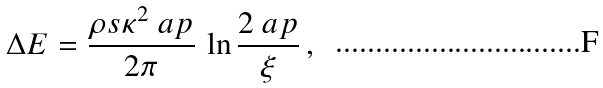<formula> <loc_0><loc_0><loc_500><loc_500>\Delta E = \frac { \rho s \kappa ^ { 2 } \ a p } { 2 \pi } \, \ln \frac { 2 \ a p } { \xi } \, ,</formula> 